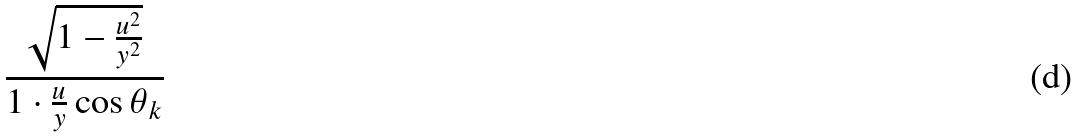Convert formula to latex. <formula><loc_0><loc_0><loc_500><loc_500>\frac { \sqrt { 1 - \frac { u ^ { 2 } } { y ^ { 2 } } } } { 1 \cdot \frac { u } { y } \cos \theta _ { k } }</formula> 